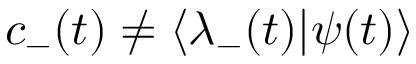Convert formula to latex. <formula><loc_0><loc_0><loc_500><loc_500>c _ { - } ( t ) \neq \langle \lambda _ { - } ( t ) | \psi ( t ) \rangle</formula> 